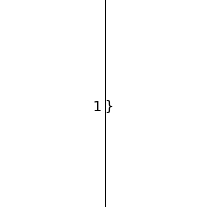<code> <loc_0><loc_0><loc_500><loc_500><_Java_>}
</code> 